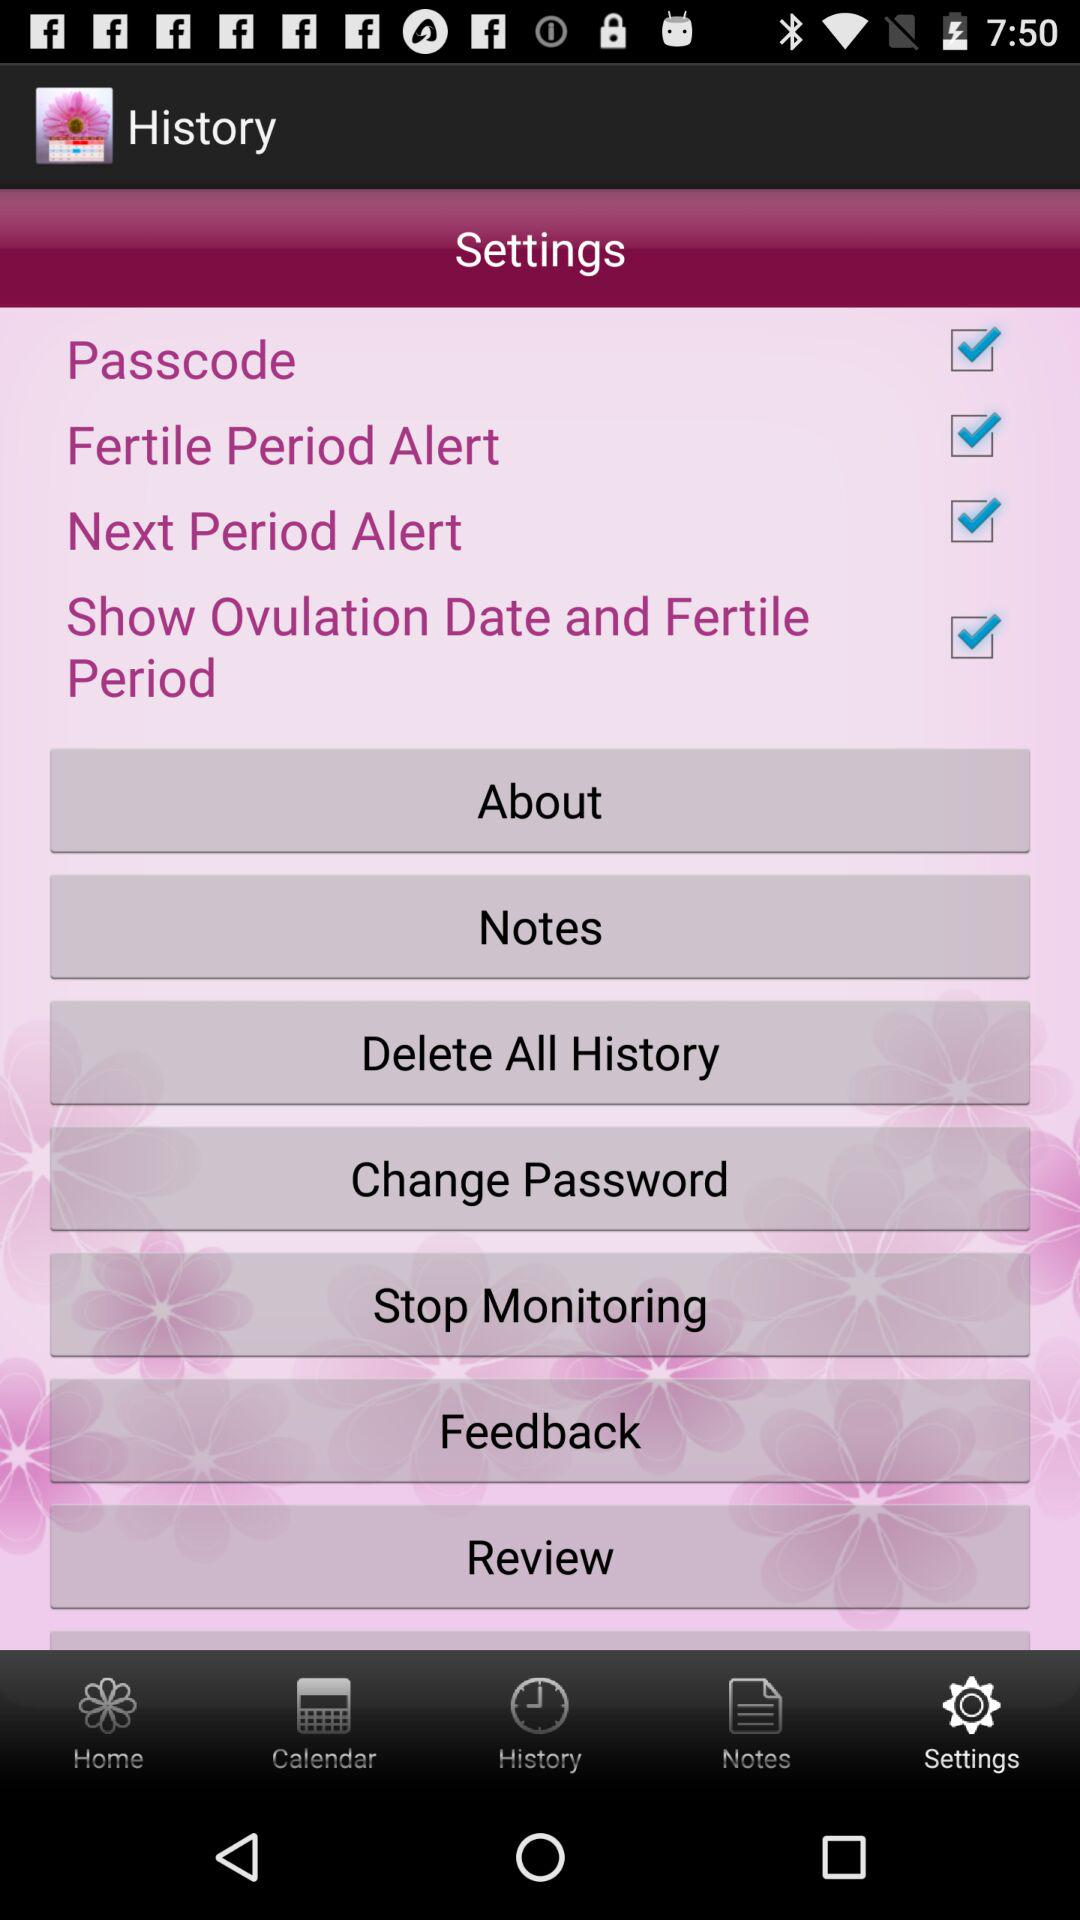Which tab is selected? The selected tab is "Settings". 